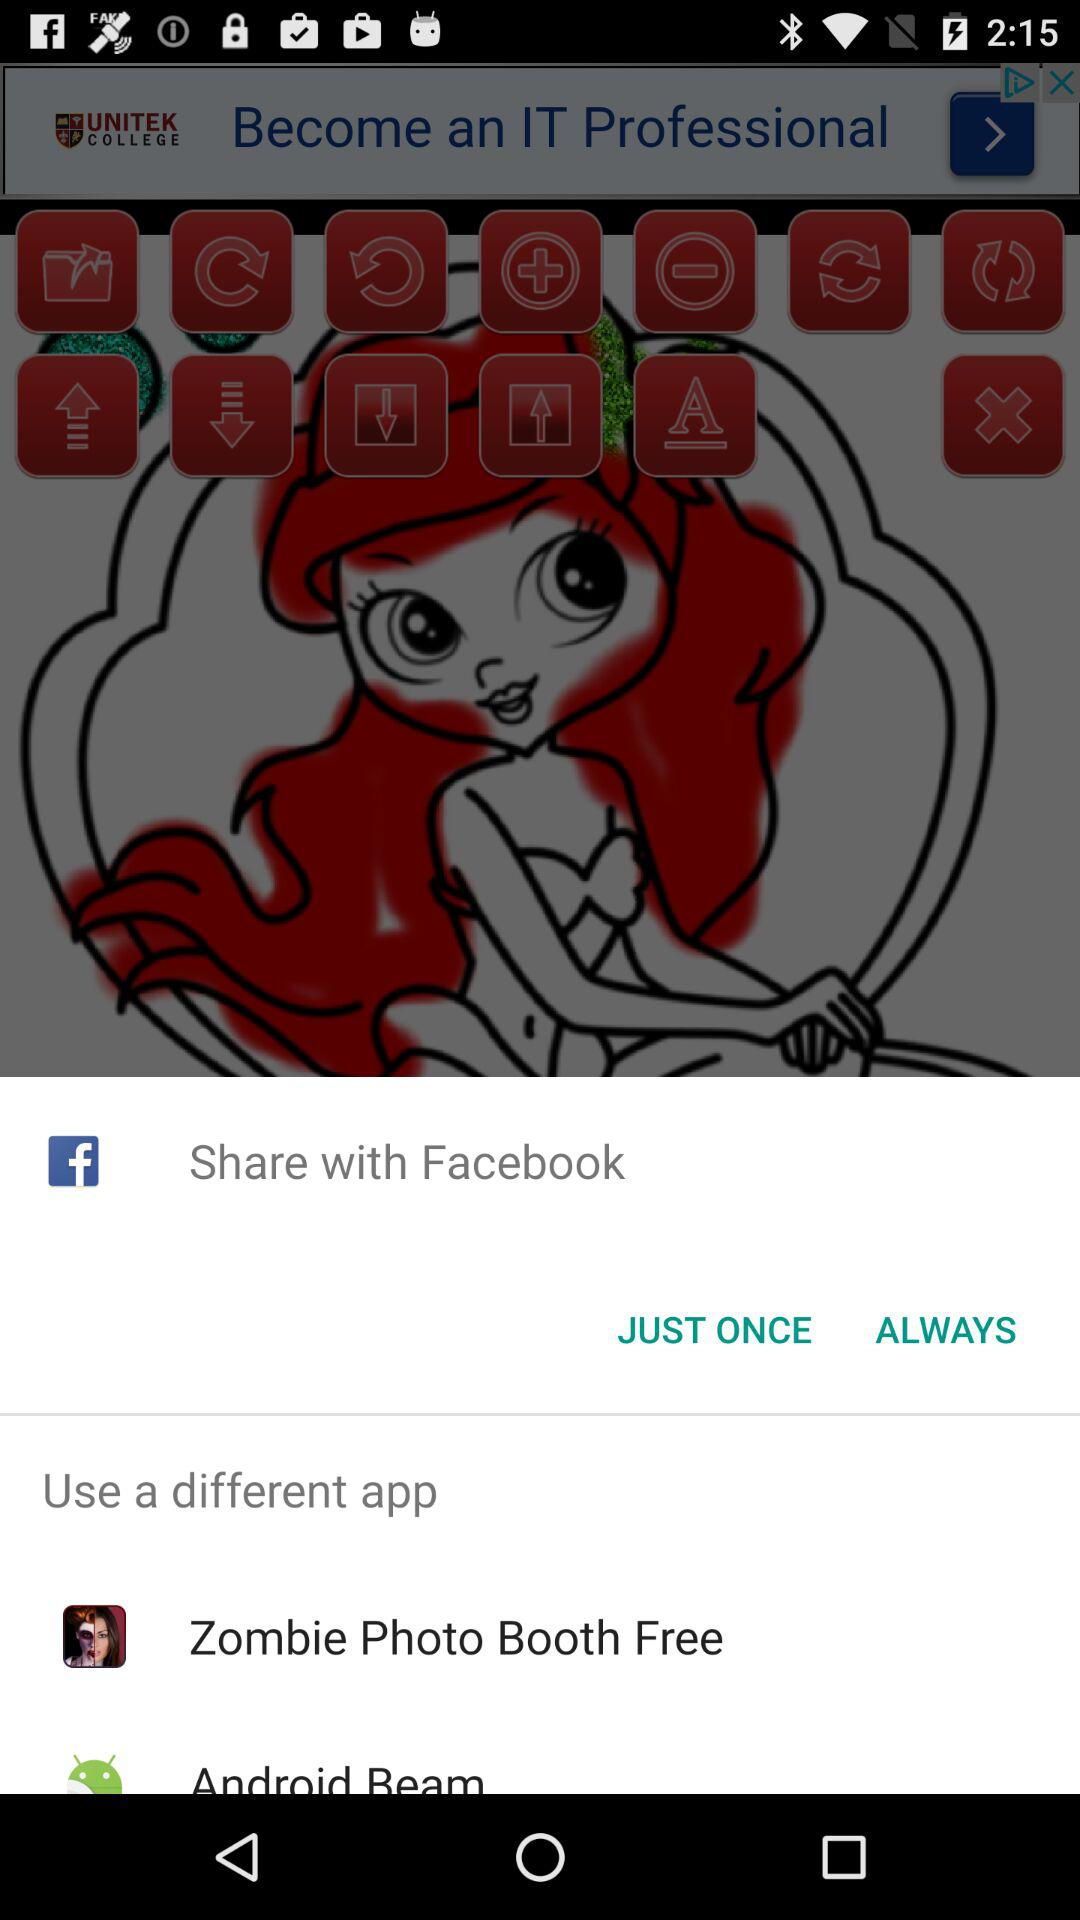What are the different apps I can use? You can use "Zombie Photo Booth Free" and "Android Beam" apps. 